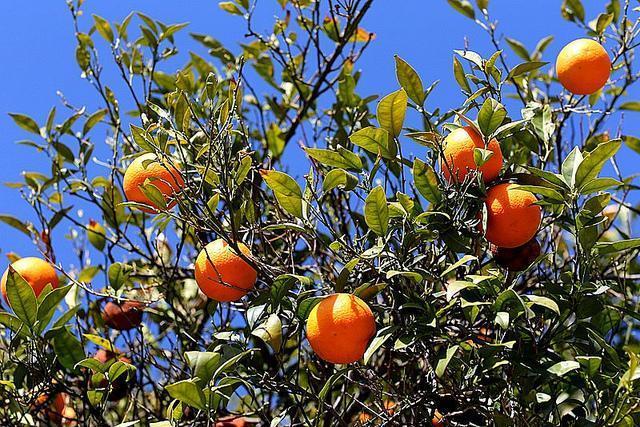How many oranges are in the picture?
Give a very brief answer. 6. How many carrots slices are in the purple container?
Give a very brief answer. 0. 